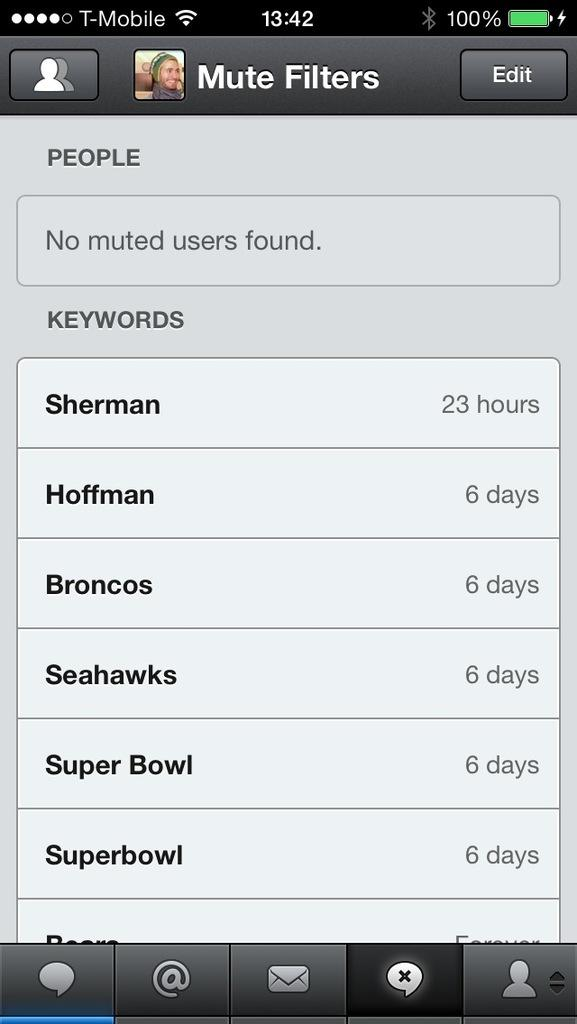What type of device is the image showing? The image is a picture of a mobile screen. What can be seen at the top of the screen? There is a WiFi symbol on the top of the screen. How much battery life is shown on the screen? The battery is at 100%. What is located at the bottom of the screen? There are logos on the bottom of the screen. What type of brass instrument is being played in the image? There is no brass instrument or any musical instrument present in the image; it is a picture of a mobile screen. What year is depicted in the image? The image does not depict a specific year; it is a mobile screen with a WiFi symbol, battery level, and logos. 